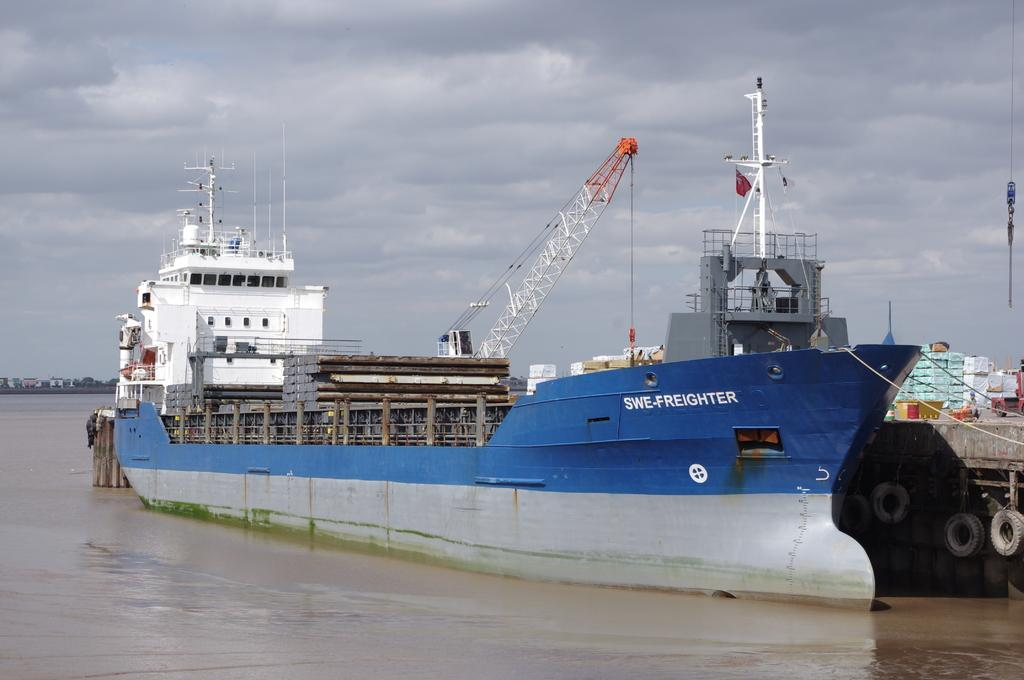What is the main subject in the center of the image? There is a ship in the center of the image on the water. What object can be seen in the image that is related to the ship? There is a rope in the image. What can be seen on a vehicle in the image? There are boxes on a vehicle in the image. What type of natural environment is visible in the background of the image? There are trees in the background of the image. What type of man-made structures can be seen in the background of the image? There are houses in the background of the image. What is visible in the sky in the background of the image? The sky is visible in the background of the image. What type of bear can be seen expressing anger in the image? There is no bear present in the image, and therefore no such expression of anger can be observed. 